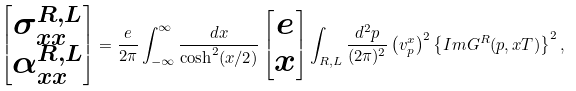Convert formula to latex. <formula><loc_0><loc_0><loc_500><loc_500>\begin{bmatrix} \sigma _ { x x } ^ { R , L } \\ \alpha _ { x x } ^ { R , L } \end{bmatrix} = \frac { e } { 2 \pi } \int _ { - \infty } ^ { \infty } \frac { d x } { \cosh ^ { 2 } ( x / 2 ) } \begin{bmatrix} e \\ x \end{bmatrix} \int _ { R , L } \frac { d ^ { 2 } p } { ( 2 \pi ) ^ { 2 } } \left ( v _ { p } ^ { x } \right ) ^ { 2 } \left \{ I m G ^ { R } ( p , x T ) \right \} ^ { 2 } ,</formula> 